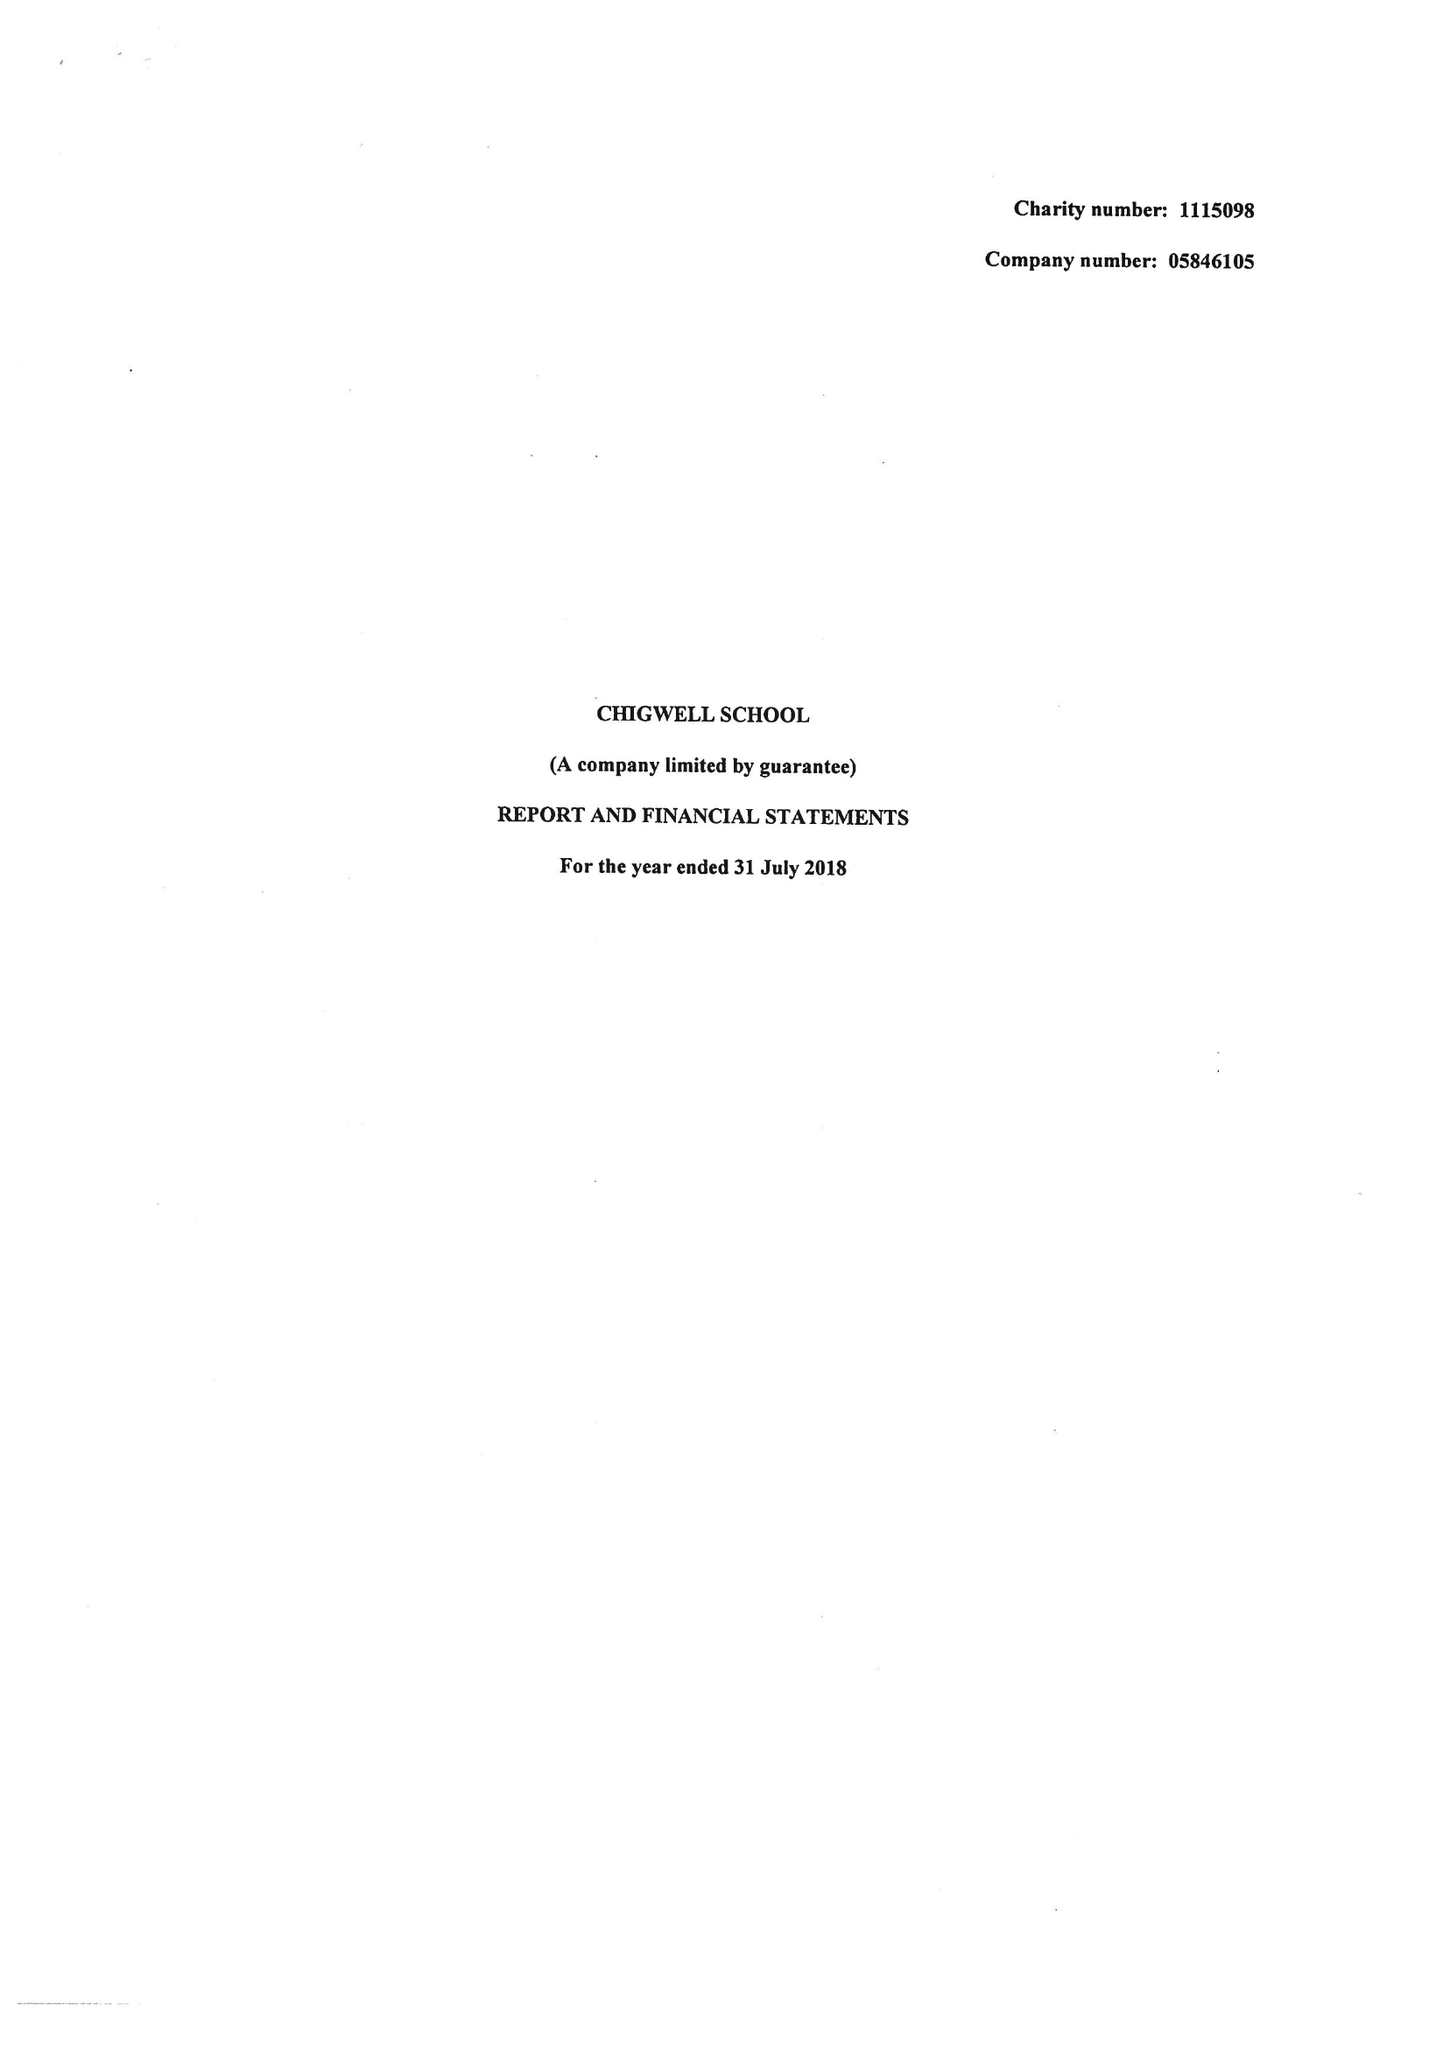What is the value for the address__post_town?
Answer the question using a single word or phrase. CHIGWELL 